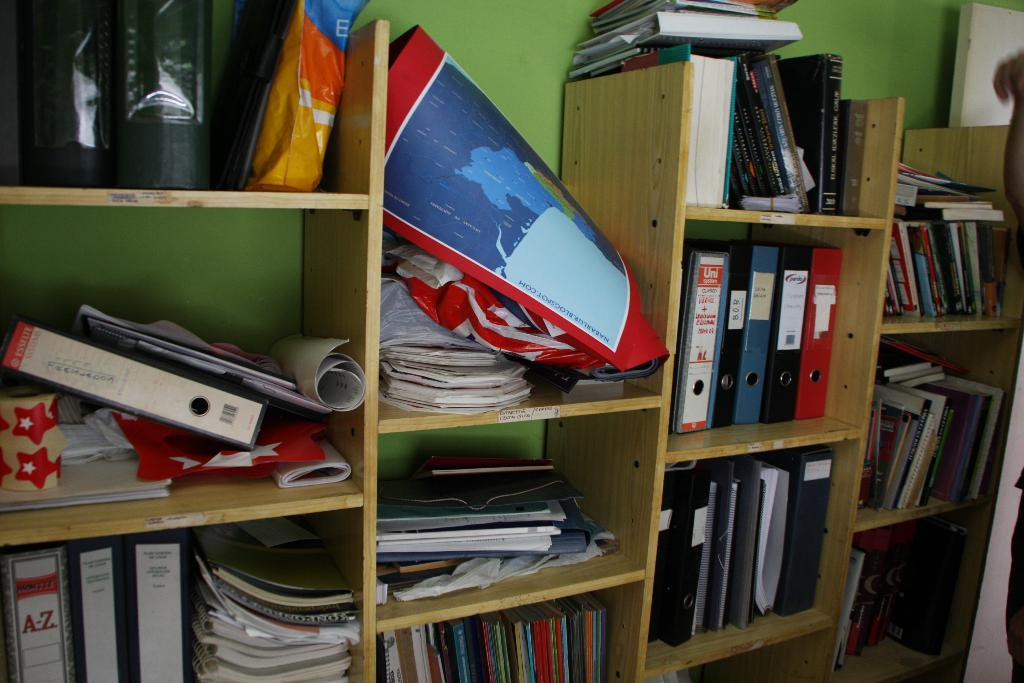What type of items can be seen in the image? There are books and papers in the image. How are the books and papers organized? The books and papers are in racks. What color is the background wall in the image? The background wall is green. How many legs does the cub have in the image? There is no cub present in the image, so it is not possible to determine the number of legs it might have. 